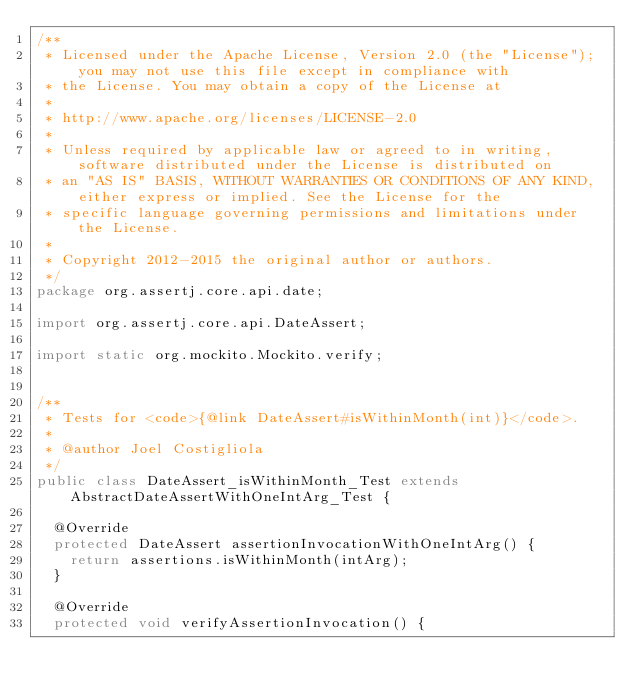<code> <loc_0><loc_0><loc_500><loc_500><_Java_>/**
 * Licensed under the Apache License, Version 2.0 (the "License"); you may not use this file except in compliance with
 * the License. You may obtain a copy of the License at
 *
 * http://www.apache.org/licenses/LICENSE-2.0
 *
 * Unless required by applicable law or agreed to in writing, software distributed under the License is distributed on
 * an "AS IS" BASIS, WITHOUT WARRANTIES OR CONDITIONS OF ANY KIND, either express or implied. See the License for the
 * specific language governing permissions and limitations under the License.
 *
 * Copyright 2012-2015 the original author or authors.
 */
package org.assertj.core.api.date;

import org.assertj.core.api.DateAssert;

import static org.mockito.Mockito.verify;


/**
 * Tests for <code>{@link DateAssert#isWithinMonth(int)}</code>.
 * 
 * @author Joel Costigliola
 */
public class DateAssert_isWithinMonth_Test extends AbstractDateAssertWithOneIntArg_Test {

  @Override
  protected DateAssert assertionInvocationWithOneIntArg() {
    return assertions.isWithinMonth(intArg);
  }

  @Override
  protected void verifyAssertionInvocation() {</code> 